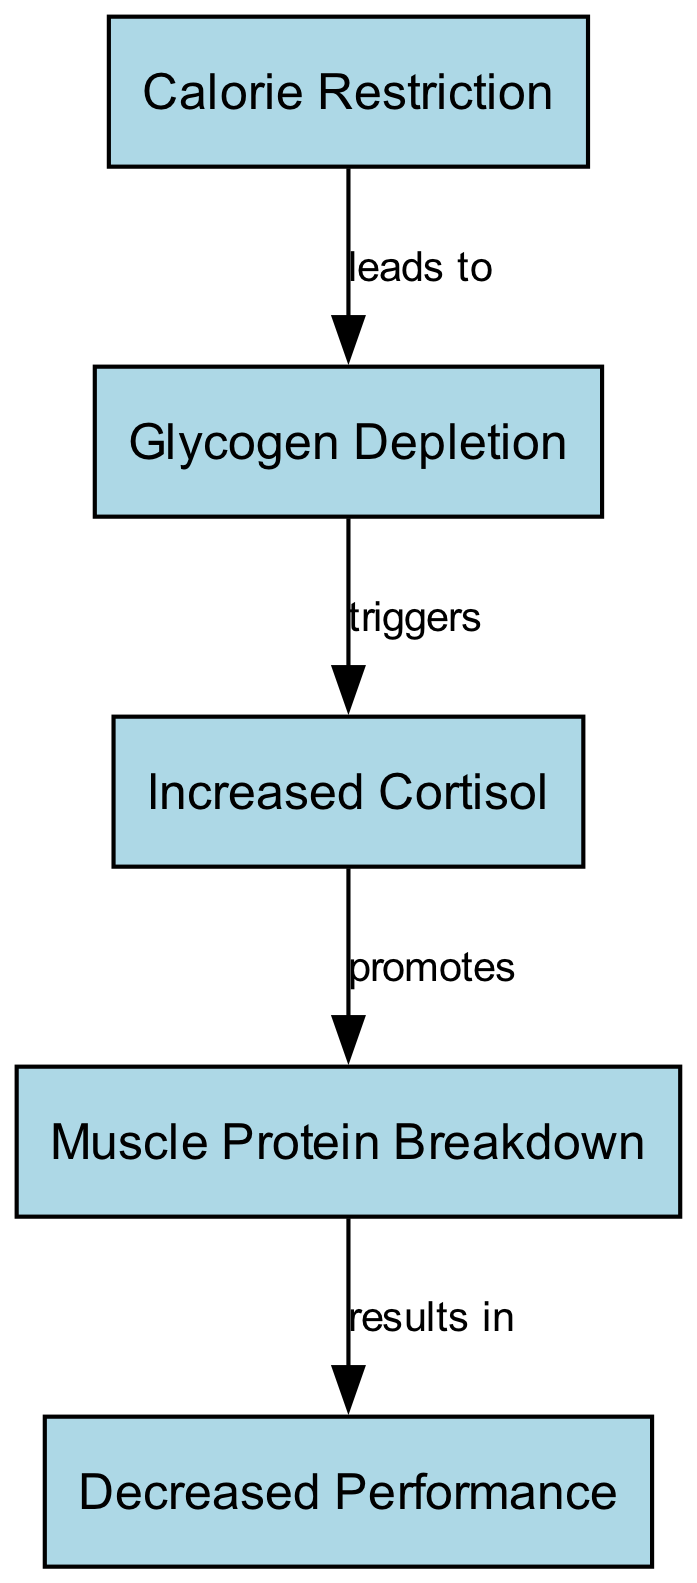What node follows Calorie Restriction? The diagram shows that Calorie Restriction leads to Glycogen Depletion, making Glycogen Depletion the node that follows Calorie Restriction.
Answer: Glycogen Depletion How many edges are in the diagram? By counting the connections between nodes, we find there are four edges that link the nodes together, representing the relationships described.
Answer: Four What does Increased Cortisol promote? Following the flow of the diagram, Increased Cortisol promotes Muscle Protein Breakdown, which is the node directly connected to it.
Answer: Muscle Protein Breakdown Which node results from Muscle Protein Breakdown? The diagram indicates that Muscle Protein Breakdown results in Decreased Performance, showing the outcome of the process described in the previous nodes.
Answer: Decreased Performance What triggers Increased Cortisol? According to the diagram, Glycogen Depletion is shown to trigger Increased Cortisol, providing a direct relationship between these two nodes.
Answer: Glycogen Depletion What is the starting node in this food chain? The starting point of the food chain is indicated to be Calorie Restriction, as it is the first node in the flow of the diagram.
Answer: Calorie Restriction What is the relationship between Glycogen Depletion and Increased Cortisol? The diagram specifies that Glycogen Depletion triggers Increased Cortisol, highlighting the cause-and-effect relationship between these two nodes.
Answer: Triggers What is the final outcome of the food chain? Following the flow through all the nodes, we see that the final outcome of the food chain is Decreased Performance, representing the end result of the processes shown.
Answer: Decreased Performance How many nodes are in the diagram? Counting all unique nodes presented, we find that there are five nodes showcasing different metabolic processes in this food chain.
Answer: Five 